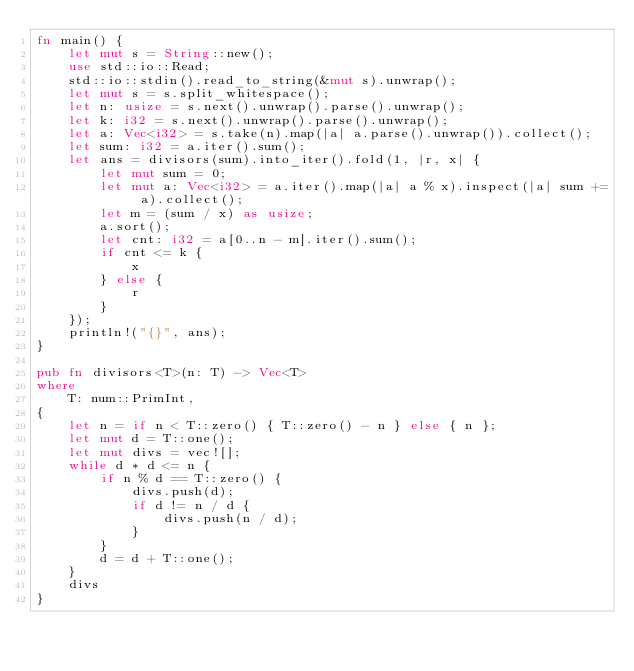Convert code to text. <code><loc_0><loc_0><loc_500><loc_500><_Rust_>fn main() {
	let mut s = String::new();
	use std::io::Read;
	std::io::stdin().read_to_string(&mut s).unwrap();
	let mut s = s.split_whitespace();
	let n: usize = s.next().unwrap().parse().unwrap();
	let k: i32 = s.next().unwrap().parse().unwrap();
	let a: Vec<i32> = s.take(n).map(|a| a.parse().unwrap()).collect();
	let sum: i32 = a.iter().sum();
	let ans = divisors(sum).into_iter().fold(1, |r, x| {
		let mut sum = 0;
		let mut a: Vec<i32> = a.iter().map(|a| a % x).inspect(|a| sum += a).collect();
		let m = (sum / x) as usize;
		a.sort();
		let cnt: i32 = a[0..n - m].iter().sum();
		if cnt <= k {
			x
		} else {
			r
		}
	});
	println!("{}", ans);
}

pub fn divisors<T>(n: T) -> Vec<T>
where
	T: num::PrimInt,
{
	let n = if n < T::zero() { T::zero() - n } else { n };
	let mut d = T::one();
	let mut divs = vec![];
	while d * d <= n {
		if n % d == T::zero() {
			divs.push(d);
			if d != n / d {
				divs.push(n / d);
			}
		}
		d = d + T::one();
	}
	divs
}
</code> 